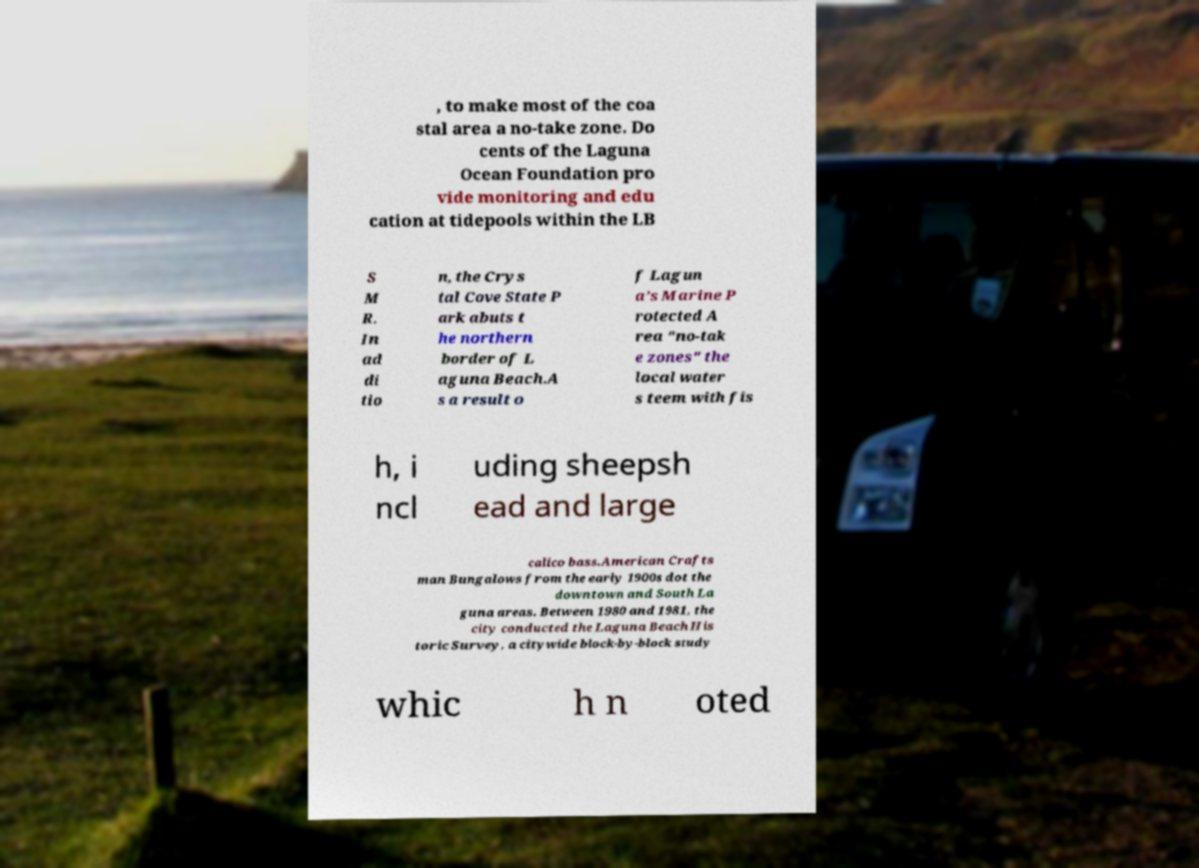What messages or text are displayed in this image? I need them in a readable, typed format. , to make most of the coa stal area a no-take zone. Do cents of the Laguna Ocean Foundation pro vide monitoring and edu cation at tidepools within the LB S M R. In ad di tio n, the Crys tal Cove State P ark abuts t he northern border of L aguna Beach.A s a result o f Lagun a’s Marine P rotected A rea "no-tak e zones" the local water s teem with fis h, i ncl uding sheepsh ead and large calico bass.American Crafts man Bungalows from the early 1900s dot the downtown and South La guna areas. Between 1980 and 1981, the city conducted the Laguna Beach His toric Survey, a citywide block-by-block study whic h n oted 